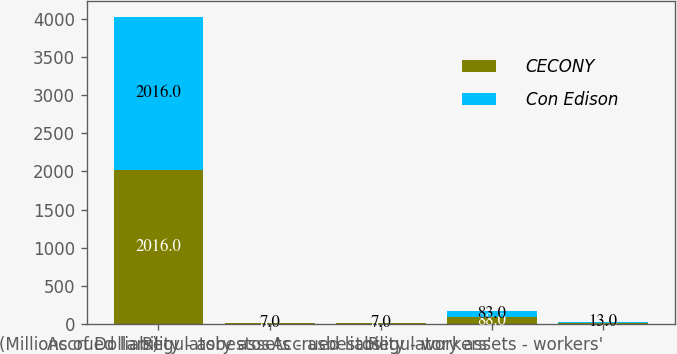Convert chart to OTSL. <chart><loc_0><loc_0><loc_500><loc_500><stacked_bar_chart><ecel><fcel>(Millions of Dollars)<fcel>Accrued liability - asbestos<fcel>Regulatory assets - asbestos<fcel>Accrued liability - workers'<fcel>Regulatory assets - workers'<nl><fcel>CECONY<fcel>2016<fcel>8<fcel>8<fcel>88<fcel>13<nl><fcel>Con Edison<fcel>2016<fcel>7<fcel>7<fcel>83<fcel>13<nl></chart> 